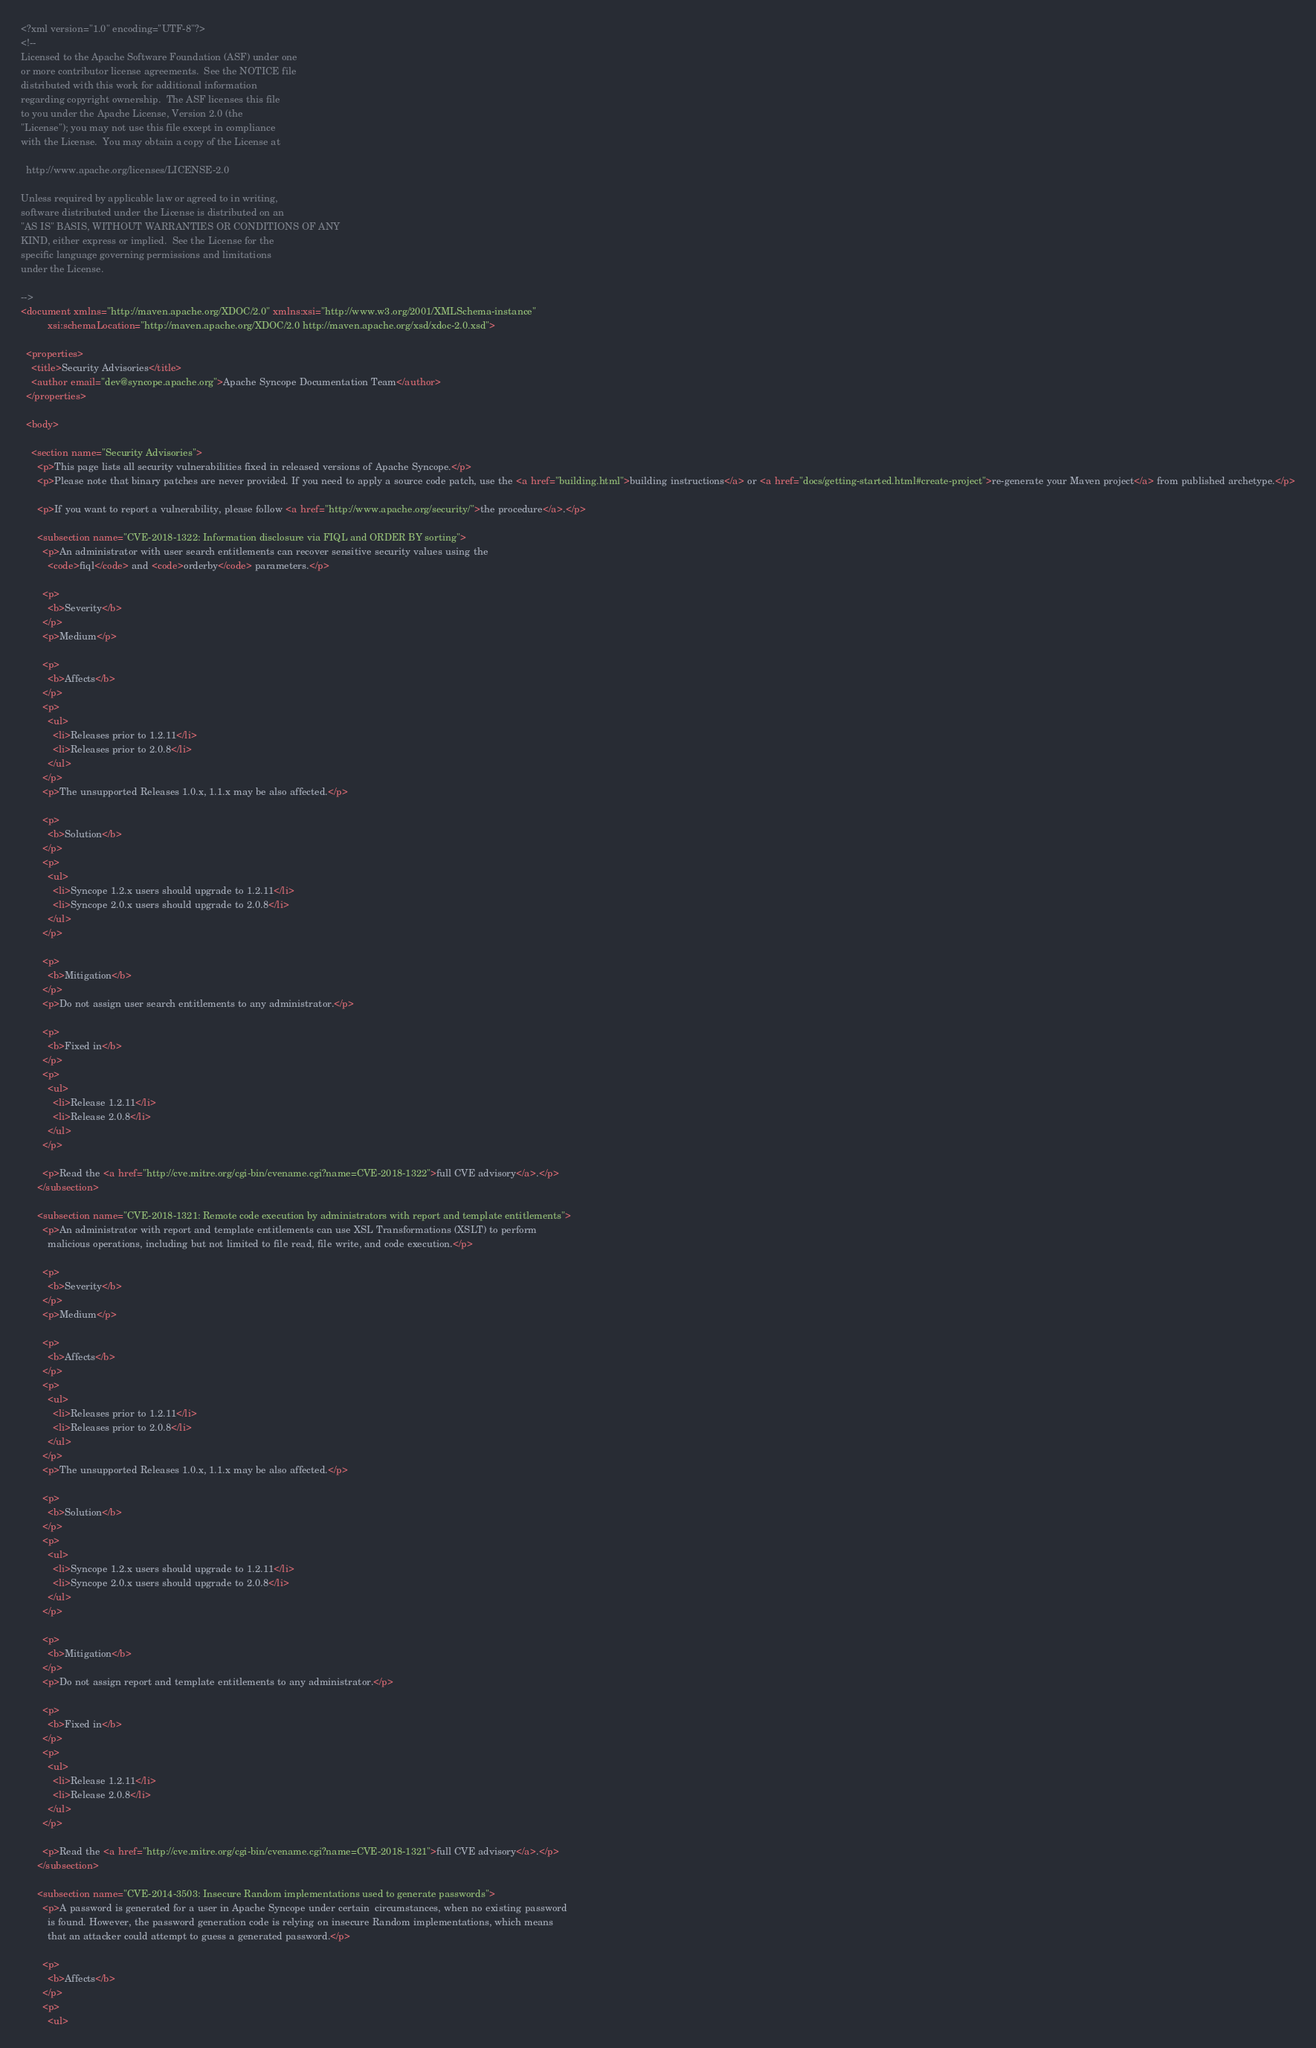<code> <loc_0><loc_0><loc_500><loc_500><_XML_><?xml version="1.0" encoding="UTF-8"?>
<!--
Licensed to the Apache Software Foundation (ASF) under one
or more contributor license agreements.  See the NOTICE file
distributed with this work for additional information
regarding copyright ownership.  The ASF licenses this file
to you under the Apache License, Version 2.0 (the
"License"); you may not use this file except in compliance
with the License.  You may obtain a copy of the License at

  http://www.apache.org/licenses/LICENSE-2.0

Unless required by applicable law or agreed to in writing,
software distributed under the License is distributed on an
"AS IS" BASIS, WITHOUT WARRANTIES OR CONDITIONS OF ANY
KIND, either express or implied.  See the License for the
specific language governing permissions and limitations
under the License.

-->
<document xmlns="http://maven.apache.org/XDOC/2.0" xmlns:xsi="http://www.w3.org/2001/XMLSchema-instance"
          xsi:schemaLocation="http://maven.apache.org/XDOC/2.0 http://maven.apache.org/xsd/xdoc-2.0.xsd">

  <properties>
    <title>Security Advisories</title>
    <author email="dev@syncope.apache.org">Apache Syncope Documentation Team</author>
  </properties>

  <body>

    <section name="Security Advisories">
      <p>This page lists all security vulnerabilities fixed in released versions of Apache Syncope.</p>
      <p>Please note that binary patches are never provided. If you need to apply a source code patch, use the <a href="building.html">building instructions</a> or <a href="docs/getting-started.html#create-project">re-generate your Maven project</a> from published archetype.</p>

      <p>If you want to report a vulnerability, please follow <a href="http://www.apache.org/security/">the procedure</a>.</p>

      <subsection name="CVE-2018-1322: Information disclosure via FIQL and ORDER BY sorting">	
        <p>An administrator with user search entitlements can recover sensitive security values using the
          <code>fiql</code> and <code>orderby</code> parameters.</p>

        <p>
          <b>Severity</b>
        </p>
        <p>Medium</p>

        <p>
          <b>Affects</b>
        </p>
        <p>
          <ul>
            <li>Releases prior to 1.2.11</li>
            <li>Releases prior to 2.0.8</li>
          </ul>
        </p>
        <p>The unsupported Releases 1.0.x, 1.1.x may be also affected.</p>

        <p>
          <b>Solution</b>
        </p>
        <p>
          <ul>
            <li>Syncope 1.2.x users should upgrade to 1.2.11</li>
            <li>Syncope 2.0.x users should upgrade to 2.0.8</li>
          </ul>          
        </p>
        
        <p>
          <b>Mitigation</b>
        </p>
        <p>Do not assign user search entitlements to any administrator.</p>

        <p>
          <b>Fixed in</b>
        </p>
        <p>
          <ul>
            <li>Release 1.2.11</li>
            <li>Release 2.0.8</li>
          </ul>
        </p>

        <p>Read the <a href="http://cve.mitre.org/cgi-bin/cvename.cgi?name=CVE-2018-1322">full CVE advisory</a>.</p>
      </subsection>

      <subsection name="CVE-2018-1321: Remote code execution by administrators with report and template entitlements">	
        <p>An administrator with report and template entitlements can use XSL Transformations (XSLT) to perform
          malicious operations, including but not limited to file read, file write, and code execution.</p>

        <p>
          <b>Severity</b>
        </p>
        <p>Medium</p>

        <p>
          <b>Affects</b>
        </p>
        <p>
          <ul>
            <li>Releases prior to 1.2.11</li>
            <li>Releases prior to 2.0.8</li>
          </ul>
        </p>
        <p>The unsupported Releases 1.0.x, 1.1.x may be also affected.</p>

        <p>
          <b>Solution</b>
        </p>
        <p>
          <ul>
            <li>Syncope 1.2.x users should upgrade to 1.2.11</li>
            <li>Syncope 2.0.x users should upgrade to 2.0.8</li>
          </ul>          
        </p>
        
        <p>
          <b>Mitigation</b>
        </p>
        <p>Do not assign report and template entitlements to any administrator.</p>

        <p>
          <b>Fixed in</b>
        </p>
        <p>
          <ul>
            <li>Release 1.2.11</li>
            <li>Release 2.0.8</li>
          </ul>
        </p>

        <p>Read the <a href="http://cve.mitre.org/cgi-bin/cvename.cgi?name=CVE-2018-1321">full CVE advisory</a>.</p>
      </subsection>

      <subsection name="CVE-2014-3503: Insecure Random implementations used to generate passwords">	
        <p>A password is generated for a user in Apache Syncope under certain  circumstances, when no existing password 
          is found. However, the password generation code is relying on insecure Random implementations, which means 
          that an attacker could attempt to guess a generated password.</p>

        <p>
          <b>Affects</b>
        </p>
        <p>
          <ul></code> 